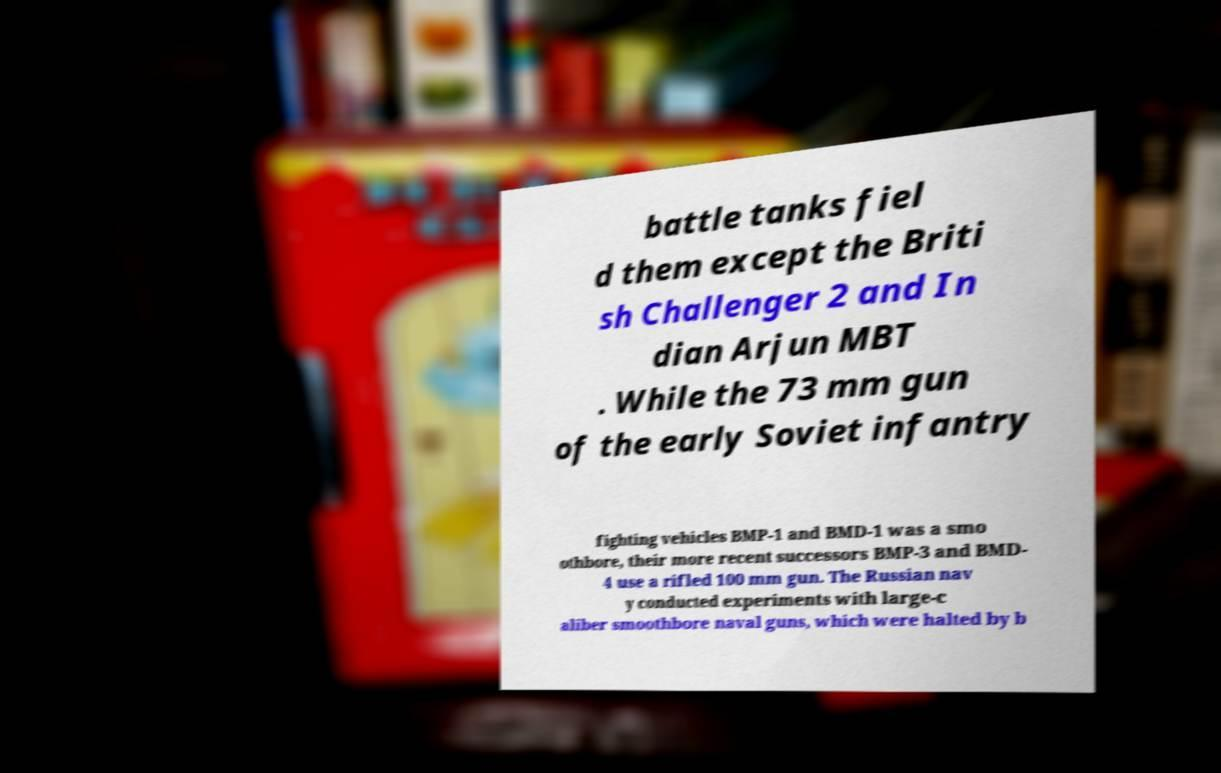There's text embedded in this image that I need extracted. Can you transcribe it verbatim? battle tanks fiel d them except the Briti sh Challenger 2 and In dian Arjun MBT . While the 73 mm gun of the early Soviet infantry fighting vehicles BMP-1 and BMD-1 was a smo othbore, their more recent successors BMP-3 and BMD- 4 use a rifled 100 mm gun. The Russian nav y conducted experiments with large-c aliber smoothbore naval guns, which were halted by b 